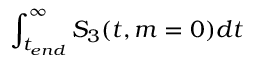<formula> <loc_0><loc_0><loc_500><loc_500>\int _ { t _ { e n d } } ^ { \infty } S _ { 3 } ( t , m = 0 ) d t</formula> 